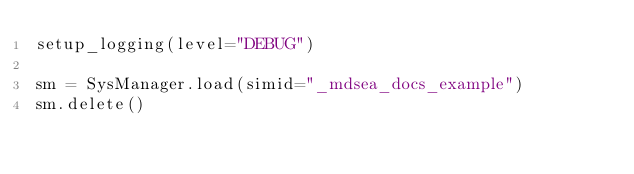<code> <loc_0><loc_0><loc_500><loc_500><_Python_>setup_logging(level="DEBUG")

sm = SysManager.load(simid="_mdsea_docs_example")
sm.delete()
</code> 